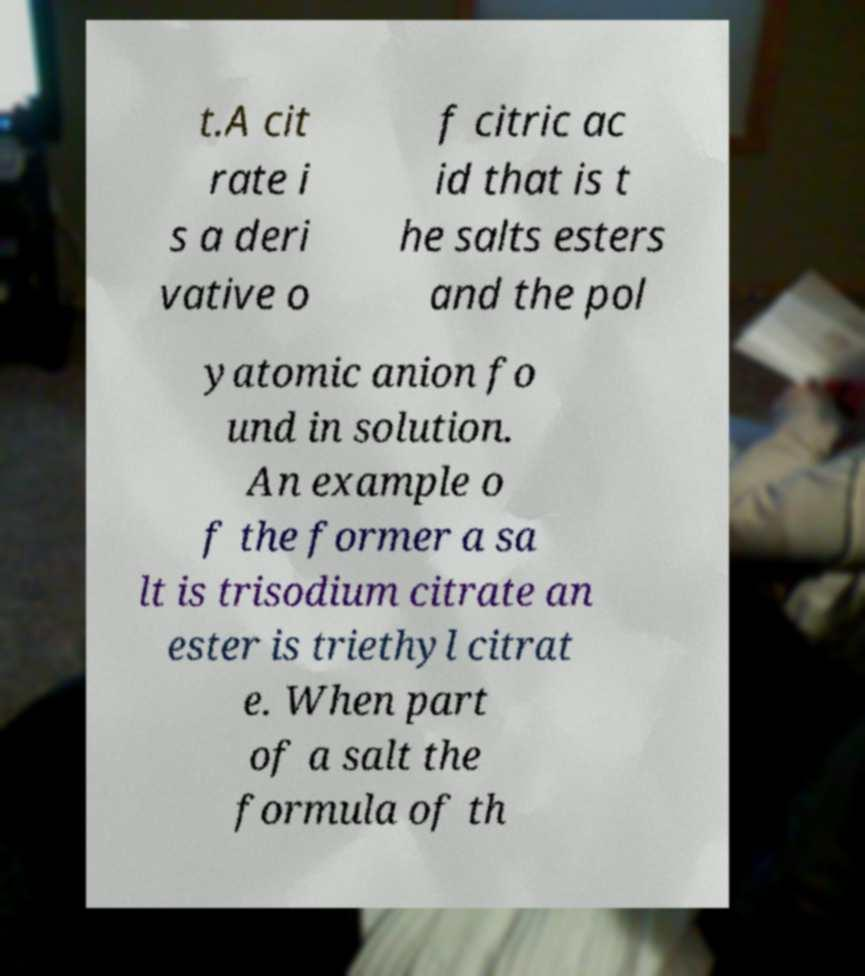For documentation purposes, I need the text within this image transcribed. Could you provide that? t.A cit rate i s a deri vative o f citric ac id that is t he salts esters and the pol yatomic anion fo und in solution. An example o f the former a sa lt is trisodium citrate an ester is triethyl citrat e. When part of a salt the formula of th 